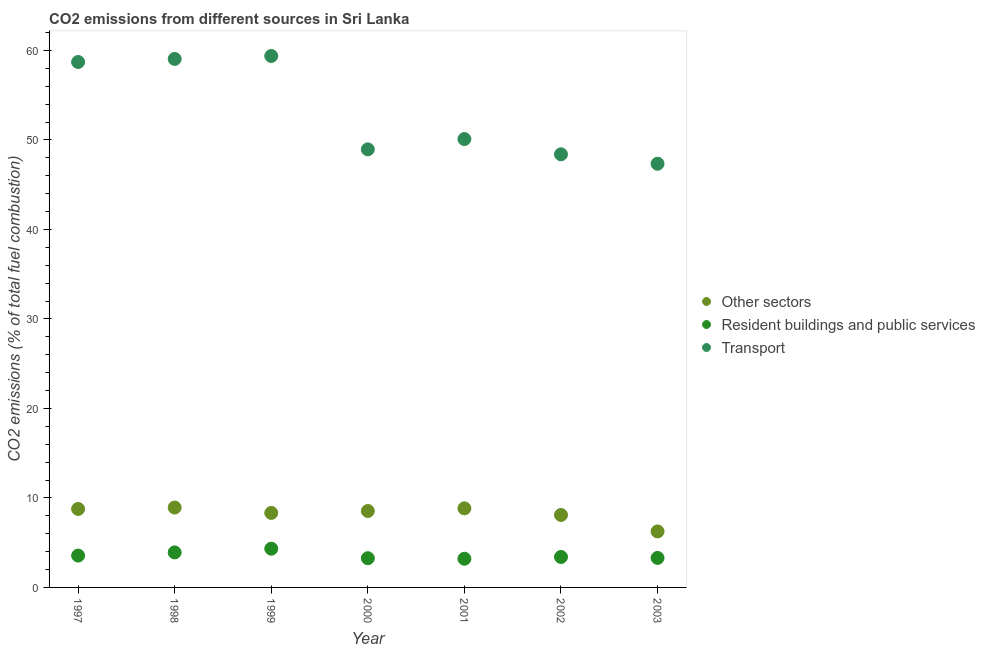How many different coloured dotlines are there?
Your answer should be compact. 3. What is the percentage of co2 emissions from transport in 1997?
Your response must be concise. 58.7. Across all years, what is the maximum percentage of co2 emissions from resident buildings and public services?
Provide a short and direct response. 4.33. Across all years, what is the minimum percentage of co2 emissions from other sectors?
Your response must be concise. 6.26. What is the total percentage of co2 emissions from resident buildings and public services in the graph?
Ensure brevity in your answer.  24.97. What is the difference between the percentage of co2 emissions from other sectors in 1999 and that in 2001?
Your response must be concise. -0.51. What is the difference between the percentage of co2 emissions from other sectors in 2001 and the percentage of co2 emissions from transport in 1998?
Keep it short and to the point. -50.21. What is the average percentage of co2 emissions from transport per year?
Give a very brief answer. 53.13. In the year 1999, what is the difference between the percentage of co2 emissions from resident buildings and public services and percentage of co2 emissions from transport?
Ensure brevity in your answer.  -55.05. What is the ratio of the percentage of co2 emissions from resident buildings and public services in 1998 to that in 2002?
Your answer should be compact. 1.15. Is the percentage of co2 emissions from resident buildings and public services in 1999 less than that in 2002?
Give a very brief answer. No. Is the difference between the percentage of co2 emissions from transport in 1997 and 1999 greater than the difference between the percentage of co2 emissions from resident buildings and public services in 1997 and 1999?
Provide a short and direct response. Yes. What is the difference between the highest and the second highest percentage of co2 emissions from transport?
Your answer should be compact. 0.33. What is the difference between the highest and the lowest percentage of co2 emissions from resident buildings and public services?
Provide a succinct answer. 1.12. Is the sum of the percentage of co2 emissions from other sectors in 1997 and 1999 greater than the maximum percentage of co2 emissions from resident buildings and public services across all years?
Provide a succinct answer. Yes. Is it the case that in every year, the sum of the percentage of co2 emissions from other sectors and percentage of co2 emissions from resident buildings and public services is greater than the percentage of co2 emissions from transport?
Your answer should be very brief. No. Is the percentage of co2 emissions from other sectors strictly greater than the percentage of co2 emissions from resident buildings and public services over the years?
Keep it short and to the point. Yes. What is the difference between two consecutive major ticks on the Y-axis?
Keep it short and to the point. 10. Does the graph contain grids?
Provide a short and direct response. No. Where does the legend appear in the graph?
Keep it short and to the point. Center right. How many legend labels are there?
Your answer should be very brief. 3. How are the legend labels stacked?
Give a very brief answer. Vertical. What is the title of the graph?
Your answer should be compact. CO2 emissions from different sources in Sri Lanka. What is the label or title of the X-axis?
Keep it short and to the point. Year. What is the label or title of the Y-axis?
Make the answer very short. CO2 emissions (% of total fuel combustion). What is the CO2 emissions (% of total fuel combustion) of Other sectors in 1997?
Give a very brief answer. 8.77. What is the CO2 emissions (% of total fuel combustion) in Resident buildings and public services in 1997?
Provide a short and direct response. 3.56. What is the CO2 emissions (% of total fuel combustion) in Transport in 1997?
Ensure brevity in your answer.  58.7. What is the CO2 emissions (% of total fuel combustion) in Other sectors in 1998?
Offer a very short reply. 8.92. What is the CO2 emissions (% of total fuel combustion) of Resident buildings and public services in 1998?
Provide a succinct answer. 3.91. What is the CO2 emissions (% of total fuel combustion) in Transport in 1998?
Offer a terse response. 59.05. What is the CO2 emissions (% of total fuel combustion) of Other sectors in 1999?
Your answer should be compact. 8.32. What is the CO2 emissions (% of total fuel combustion) in Resident buildings and public services in 1999?
Your answer should be compact. 4.33. What is the CO2 emissions (% of total fuel combustion) in Transport in 1999?
Make the answer very short. 59.38. What is the CO2 emissions (% of total fuel combustion) of Other sectors in 2000?
Your answer should be compact. 8.54. What is the CO2 emissions (% of total fuel combustion) in Resident buildings and public services in 2000?
Ensure brevity in your answer.  3.26. What is the CO2 emissions (% of total fuel combustion) in Transport in 2000?
Give a very brief answer. 48.94. What is the CO2 emissions (% of total fuel combustion) in Other sectors in 2001?
Provide a short and direct response. 8.83. What is the CO2 emissions (% of total fuel combustion) of Resident buildings and public services in 2001?
Give a very brief answer. 3.2. What is the CO2 emissions (% of total fuel combustion) in Transport in 2001?
Provide a succinct answer. 50.1. What is the CO2 emissions (% of total fuel combustion) in Other sectors in 2002?
Offer a very short reply. 8.1. What is the CO2 emissions (% of total fuel combustion) in Resident buildings and public services in 2002?
Give a very brief answer. 3.4. What is the CO2 emissions (% of total fuel combustion) in Transport in 2002?
Make the answer very short. 48.39. What is the CO2 emissions (% of total fuel combustion) of Other sectors in 2003?
Make the answer very short. 6.26. What is the CO2 emissions (% of total fuel combustion) of Resident buildings and public services in 2003?
Offer a terse response. 3.3. What is the CO2 emissions (% of total fuel combustion) of Transport in 2003?
Provide a short and direct response. 47.34. Across all years, what is the maximum CO2 emissions (% of total fuel combustion) of Other sectors?
Keep it short and to the point. 8.92. Across all years, what is the maximum CO2 emissions (% of total fuel combustion) of Resident buildings and public services?
Offer a very short reply. 4.33. Across all years, what is the maximum CO2 emissions (% of total fuel combustion) of Transport?
Give a very brief answer. 59.38. Across all years, what is the minimum CO2 emissions (% of total fuel combustion) in Other sectors?
Give a very brief answer. 6.26. Across all years, what is the minimum CO2 emissions (% of total fuel combustion) in Resident buildings and public services?
Provide a succinct answer. 3.2. Across all years, what is the minimum CO2 emissions (% of total fuel combustion) of Transport?
Make the answer very short. 47.34. What is the total CO2 emissions (% of total fuel combustion) of Other sectors in the graph?
Offer a very short reply. 57.74. What is the total CO2 emissions (% of total fuel combustion) in Resident buildings and public services in the graph?
Keep it short and to the point. 24.97. What is the total CO2 emissions (% of total fuel combustion) of Transport in the graph?
Provide a succinct answer. 371.9. What is the difference between the CO2 emissions (% of total fuel combustion) in Other sectors in 1997 and that in 1998?
Ensure brevity in your answer.  -0.16. What is the difference between the CO2 emissions (% of total fuel combustion) in Resident buildings and public services in 1997 and that in 1998?
Your answer should be very brief. -0.35. What is the difference between the CO2 emissions (% of total fuel combustion) of Transport in 1997 and that in 1998?
Make the answer very short. -0.34. What is the difference between the CO2 emissions (% of total fuel combustion) in Other sectors in 1997 and that in 1999?
Your response must be concise. 0.44. What is the difference between the CO2 emissions (% of total fuel combustion) in Resident buildings and public services in 1997 and that in 1999?
Your answer should be compact. -0.77. What is the difference between the CO2 emissions (% of total fuel combustion) in Transport in 1997 and that in 1999?
Provide a short and direct response. -0.67. What is the difference between the CO2 emissions (% of total fuel combustion) in Other sectors in 1997 and that in 2000?
Make the answer very short. 0.23. What is the difference between the CO2 emissions (% of total fuel combustion) of Resident buildings and public services in 1997 and that in 2000?
Your response must be concise. 0.29. What is the difference between the CO2 emissions (% of total fuel combustion) of Transport in 1997 and that in 2000?
Your answer should be very brief. 9.76. What is the difference between the CO2 emissions (% of total fuel combustion) in Other sectors in 1997 and that in 2001?
Your response must be concise. -0.07. What is the difference between the CO2 emissions (% of total fuel combustion) of Resident buildings and public services in 1997 and that in 2001?
Your answer should be compact. 0.35. What is the difference between the CO2 emissions (% of total fuel combustion) of Transport in 1997 and that in 2001?
Your response must be concise. 8.61. What is the difference between the CO2 emissions (% of total fuel combustion) in Other sectors in 1997 and that in 2002?
Your response must be concise. 0.67. What is the difference between the CO2 emissions (% of total fuel combustion) in Resident buildings and public services in 1997 and that in 2002?
Provide a short and direct response. 0.15. What is the difference between the CO2 emissions (% of total fuel combustion) of Transport in 1997 and that in 2002?
Provide a succinct answer. 10.31. What is the difference between the CO2 emissions (% of total fuel combustion) in Other sectors in 1997 and that in 2003?
Ensure brevity in your answer.  2.51. What is the difference between the CO2 emissions (% of total fuel combustion) in Resident buildings and public services in 1997 and that in 2003?
Provide a succinct answer. 0.26. What is the difference between the CO2 emissions (% of total fuel combustion) of Transport in 1997 and that in 2003?
Provide a short and direct response. 11.37. What is the difference between the CO2 emissions (% of total fuel combustion) of Other sectors in 1998 and that in 1999?
Your response must be concise. 0.6. What is the difference between the CO2 emissions (% of total fuel combustion) in Resident buildings and public services in 1998 and that in 1999?
Provide a short and direct response. -0.42. What is the difference between the CO2 emissions (% of total fuel combustion) of Transport in 1998 and that in 1999?
Make the answer very short. -0.33. What is the difference between the CO2 emissions (% of total fuel combustion) in Other sectors in 1998 and that in 2000?
Offer a terse response. 0.38. What is the difference between the CO2 emissions (% of total fuel combustion) in Resident buildings and public services in 1998 and that in 2000?
Your response must be concise. 0.65. What is the difference between the CO2 emissions (% of total fuel combustion) of Transport in 1998 and that in 2000?
Give a very brief answer. 10.1. What is the difference between the CO2 emissions (% of total fuel combustion) of Other sectors in 1998 and that in 2001?
Your answer should be compact. 0.09. What is the difference between the CO2 emissions (% of total fuel combustion) in Resident buildings and public services in 1998 and that in 2001?
Provide a succinct answer. 0.71. What is the difference between the CO2 emissions (% of total fuel combustion) in Transport in 1998 and that in 2001?
Your answer should be compact. 8.95. What is the difference between the CO2 emissions (% of total fuel combustion) of Other sectors in 1998 and that in 2002?
Keep it short and to the point. 0.83. What is the difference between the CO2 emissions (% of total fuel combustion) in Resident buildings and public services in 1998 and that in 2002?
Keep it short and to the point. 0.51. What is the difference between the CO2 emissions (% of total fuel combustion) of Transport in 1998 and that in 2002?
Keep it short and to the point. 10.66. What is the difference between the CO2 emissions (% of total fuel combustion) in Other sectors in 1998 and that in 2003?
Your answer should be compact. 2.67. What is the difference between the CO2 emissions (% of total fuel combustion) in Resident buildings and public services in 1998 and that in 2003?
Keep it short and to the point. 0.62. What is the difference between the CO2 emissions (% of total fuel combustion) in Transport in 1998 and that in 2003?
Make the answer very short. 11.71. What is the difference between the CO2 emissions (% of total fuel combustion) in Other sectors in 1999 and that in 2000?
Provide a succinct answer. -0.22. What is the difference between the CO2 emissions (% of total fuel combustion) of Resident buildings and public services in 1999 and that in 2000?
Your answer should be compact. 1.07. What is the difference between the CO2 emissions (% of total fuel combustion) in Transport in 1999 and that in 2000?
Provide a succinct answer. 10.43. What is the difference between the CO2 emissions (% of total fuel combustion) in Other sectors in 1999 and that in 2001?
Give a very brief answer. -0.51. What is the difference between the CO2 emissions (% of total fuel combustion) of Resident buildings and public services in 1999 and that in 2001?
Provide a short and direct response. 1.12. What is the difference between the CO2 emissions (% of total fuel combustion) of Transport in 1999 and that in 2001?
Your response must be concise. 9.28. What is the difference between the CO2 emissions (% of total fuel combustion) of Other sectors in 1999 and that in 2002?
Make the answer very short. 0.23. What is the difference between the CO2 emissions (% of total fuel combustion) in Resident buildings and public services in 1999 and that in 2002?
Your answer should be very brief. 0.92. What is the difference between the CO2 emissions (% of total fuel combustion) of Transport in 1999 and that in 2002?
Offer a very short reply. 10.99. What is the difference between the CO2 emissions (% of total fuel combustion) of Other sectors in 1999 and that in 2003?
Ensure brevity in your answer.  2.07. What is the difference between the CO2 emissions (% of total fuel combustion) of Resident buildings and public services in 1999 and that in 2003?
Your response must be concise. 1.03. What is the difference between the CO2 emissions (% of total fuel combustion) of Transport in 1999 and that in 2003?
Offer a terse response. 12.04. What is the difference between the CO2 emissions (% of total fuel combustion) of Other sectors in 2000 and that in 2001?
Offer a terse response. -0.29. What is the difference between the CO2 emissions (% of total fuel combustion) in Resident buildings and public services in 2000 and that in 2001?
Provide a short and direct response. 0.06. What is the difference between the CO2 emissions (% of total fuel combustion) in Transport in 2000 and that in 2001?
Ensure brevity in your answer.  -1.15. What is the difference between the CO2 emissions (% of total fuel combustion) of Other sectors in 2000 and that in 2002?
Give a very brief answer. 0.45. What is the difference between the CO2 emissions (% of total fuel combustion) of Resident buildings and public services in 2000 and that in 2002?
Your response must be concise. -0.14. What is the difference between the CO2 emissions (% of total fuel combustion) in Transport in 2000 and that in 2002?
Offer a very short reply. 0.55. What is the difference between the CO2 emissions (% of total fuel combustion) in Other sectors in 2000 and that in 2003?
Ensure brevity in your answer.  2.29. What is the difference between the CO2 emissions (% of total fuel combustion) in Resident buildings and public services in 2000 and that in 2003?
Give a very brief answer. -0.03. What is the difference between the CO2 emissions (% of total fuel combustion) of Transport in 2000 and that in 2003?
Provide a short and direct response. 1.61. What is the difference between the CO2 emissions (% of total fuel combustion) in Other sectors in 2001 and that in 2002?
Ensure brevity in your answer.  0.74. What is the difference between the CO2 emissions (% of total fuel combustion) of Transport in 2001 and that in 2002?
Your response must be concise. 1.71. What is the difference between the CO2 emissions (% of total fuel combustion) in Other sectors in 2001 and that in 2003?
Give a very brief answer. 2.58. What is the difference between the CO2 emissions (% of total fuel combustion) of Resident buildings and public services in 2001 and that in 2003?
Provide a succinct answer. -0.09. What is the difference between the CO2 emissions (% of total fuel combustion) in Transport in 2001 and that in 2003?
Ensure brevity in your answer.  2.76. What is the difference between the CO2 emissions (% of total fuel combustion) of Other sectors in 2002 and that in 2003?
Give a very brief answer. 1.84. What is the difference between the CO2 emissions (% of total fuel combustion) of Resident buildings and public services in 2002 and that in 2003?
Your answer should be very brief. 0.11. What is the difference between the CO2 emissions (% of total fuel combustion) of Transport in 2002 and that in 2003?
Provide a succinct answer. 1.05. What is the difference between the CO2 emissions (% of total fuel combustion) of Other sectors in 1997 and the CO2 emissions (% of total fuel combustion) of Resident buildings and public services in 1998?
Give a very brief answer. 4.86. What is the difference between the CO2 emissions (% of total fuel combustion) of Other sectors in 1997 and the CO2 emissions (% of total fuel combustion) of Transport in 1998?
Give a very brief answer. -50.28. What is the difference between the CO2 emissions (% of total fuel combustion) in Resident buildings and public services in 1997 and the CO2 emissions (% of total fuel combustion) in Transport in 1998?
Your answer should be very brief. -55.49. What is the difference between the CO2 emissions (% of total fuel combustion) of Other sectors in 1997 and the CO2 emissions (% of total fuel combustion) of Resident buildings and public services in 1999?
Provide a succinct answer. 4.44. What is the difference between the CO2 emissions (% of total fuel combustion) in Other sectors in 1997 and the CO2 emissions (% of total fuel combustion) in Transport in 1999?
Your answer should be very brief. -50.61. What is the difference between the CO2 emissions (% of total fuel combustion) in Resident buildings and public services in 1997 and the CO2 emissions (% of total fuel combustion) in Transport in 1999?
Your answer should be very brief. -55.82. What is the difference between the CO2 emissions (% of total fuel combustion) of Other sectors in 1997 and the CO2 emissions (% of total fuel combustion) of Resident buildings and public services in 2000?
Give a very brief answer. 5.5. What is the difference between the CO2 emissions (% of total fuel combustion) of Other sectors in 1997 and the CO2 emissions (% of total fuel combustion) of Transport in 2000?
Ensure brevity in your answer.  -40.18. What is the difference between the CO2 emissions (% of total fuel combustion) of Resident buildings and public services in 1997 and the CO2 emissions (% of total fuel combustion) of Transport in 2000?
Make the answer very short. -45.39. What is the difference between the CO2 emissions (% of total fuel combustion) of Other sectors in 1997 and the CO2 emissions (% of total fuel combustion) of Resident buildings and public services in 2001?
Provide a succinct answer. 5.56. What is the difference between the CO2 emissions (% of total fuel combustion) in Other sectors in 1997 and the CO2 emissions (% of total fuel combustion) in Transport in 2001?
Offer a very short reply. -41.33. What is the difference between the CO2 emissions (% of total fuel combustion) of Resident buildings and public services in 1997 and the CO2 emissions (% of total fuel combustion) of Transport in 2001?
Offer a very short reply. -46.54. What is the difference between the CO2 emissions (% of total fuel combustion) of Other sectors in 1997 and the CO2 emissions (% of total fuel combustion) of Resident buildings and public services in 2002?
Keep it short and to the point. 5.36. What is the difference between the CO2 emissions (% of total fuel combustion) of Other sectors in 1997 and the CO2 emissions (% of total fuel combustion) of Transport in 2002?
Offer a terse response. -39.62. What is the difference between the CO2 emissions (% of total fuel combustion) of Resident buildings and public services in 1997 and the CO2 emissions (% of total fuel combustion) of Transport in 2002?
Offer a very short reply. -44.83. What is the difference between the CO2 emissions (% of total fuel combustion) of Other sectors in 1997 and the CO2 emissions (% of total fuel combustion) of Resident buildings and public services in 2003?
Keep it short and to the point. 5.47. What is the difference between the CO2 emissions (% of total fuel combustion) of Other sectors in 1997 and the CO2 emissions (% of total fuel combustion) of Transport in 2003?
Ensure brevity in your answer.  -38.57. What is the difference between the CO2 emissions (% of total fuel combustion) of Resident buildings and public services in 1997 and the CO2 emissions (% of total fuel combustion) of Transport in 2003?
Keep it short and to the point. -43.78. What is the difference between the CO2 emissions (% of total fuel combustion) of Other sectors in 1998 and the CO2 emissions (% of total fuel combustion) of Resident buildings and public services in 1999?
Provide a succinct answer. 4.6. What is the difference between the CO2 emissions (% of total fuel combustion) of Other sectors in 1998 and the CO2 emissions (% of total fuel combustion) of Transport in 1999?
Your answer should be compact. -50.45. What is the difference between the CO2 emissions (% of total fuel combustion) in Resident buildings and public services in 1998 and the CO2 emissions (% of total fuel combustion) in Transport in 1999?
Your answer should be compact. -55.47. What is the difference between the CO2 emissions (% of total fuel combustion) of Other sectors in 1998 and the CO2 emissions (% of total fuel combustion) of Resident buildings and public services in 2000?
Keep it short and to the point. 5.66. What is the difference between the CO2 emissions (% of total fuel combustion) of Other sectors in 1998 and the CO2 emissions (% of total fuel combustion) of Transport in 2000?
Provide a succinct answer. -40.02. What is the difference between the CO2 emissions (% of total fuel combustion) in Resident buildings and public services in 1998 and the CO2 emissions (% of total fuel combustion) in Transport in 2000?
Offer a terse response. -45.03. What is the difference between the CO2 emissions (% of total fuel combustion) in Other sectors in 1998 and the CO2 emissions (% of total fuel combustion) in Resident buildings and public services in 2001?
Make the answer very short. 5.72. What is the difference between the CO2 emissions (% of total fuel combustion) of Other sectors in 1998 and the CO2 emissions (% of total fuel combustion) of Transport in 2001?
Give a very brief answer. -41.17. What is the difference between the CO2 emissions (% of total fuel combustion) in Resident buildings and public services in 1998 and the CO2 emissions (% of total fuel combustion) in Transport in 2001?
Ensure brevity in your answer.  -46.19. What is the difference between the CO2 emissions (% of total fuel combustion) in Other sectors in 1998 and the CO2 emissions (% of total fuel combustion) in Resident buildings and public services in 2002?
Your answer should be very brief. 5.52. What is the difference between the CO2 emissions (% of total fuel combustion) in Other sectors in 1998 and the CO2 emissions (% of total fuel combustion) in Transport in 2002?
Your response must be concise. -39.47. What is the difference between the CO2 emissions (% of total fuel combustion) in Resident buildings and public services in 1998 and the CO2 emissions (% of total fuel combustion) in Transport in 2002?
Keep it short and to the point. -44.48. What is the difference between the CO2 emissions (% of total fuel combustion) of Other sectors in 1998 and the CO2 emissions (% of total fuel combustion) of Resident buildings and public services in 2003?
Keep it short and to the point. 5.63. What is the difference between the CO2 emissions (% of total fuel combustion) of Other sectors in 1998 and the CO2 emissions (% of total fuel combustion) of Transport in 2003?
Make the answer very short. -38.41. What is the difference between the CO2 emissions (% of total fuel combustion) of Resident buildings and public services in 1998 and the CO2 emissions (% of total fuel combustion) of Transport in 2003?
Offer a terse response. -43.43. What is the difference between the CO2 emissions (% of total fuel combustion) in Other sectors in 1999 and the CO2 emissions (% of total fuel combustion) in Resident buildings and public services in 2000?
Make the answer very short. 5.06. What is the difference between the CO2 emissions (% of total fuel combustion) of Other sectors in 1999 and the CO2 emissions (% of total fuel combustion) of Transport in 2000?
Make the answer very short. -40.62. What is the difference between the CO2 emissions (% of total fuel combustion) in Resident buildings and public services in 1999 and the CO2 emissions (% of total fuel combustion) in Transport in 2000?
Offer a very short reply. -44.62. What is the difference between the CO2 emissions (% of total fuel combustion) of Other sectors in 1999 and the CO2 emissions (% of total fuel combustion) of Resident buildings and public services in 2001?
Your response must be concise. 5.12. What is the difference between the CO2 emissions (% of total fuel combustion) in Other sectors in 1999 and the CO2 emissions (% of total fuel combustion) in Transport in 2001?
Keep it short and to the point. -41.77. What is the difference between the CO2 emissions (% of total fuel combustion) of Resident buildings and public services in 1999 and the CO2 emissions (% of total fuel combustion) of Transport in 2001?
Make the answer very short. -45.77. What is the difference between the CO2 emissions (% of total fuel combustion) in Other sectors in 1999 and the CO2 emissions (% of total fuel combustion) in Resident buildings and public services in 2002?
Provide a succinct answer. 4.92. What is the difference between the CO2 emissions (% of total fuel combustion) in Other sectors in 1999 and the CO2 emissions (% of total fuel combustion) in Transport in 2002?
Provide a succinct answer. -40.07. What is the difference between the CO2 emissions (% of total fuel combustion) in Resident buildings and public services in 1999 and the CO2 emissions (% of total fuel combustion) in Transport in 2002?
Offer a terse response. -44.06. What is the difference between the CO2 emissions (% of total fuel combustion) in Other sectors in 1999 and the CO2 emissions (% of total fuel combustion) in Resident buildings and public services in 2003?
Your answer should be very brief. 5.03. What is the difference between the CO2 emissions (% of total fuel combustion) of Other sectors in 1999 and the CO2 emissions (% of total fuel combustion) of Transport in 2003?
Keep it short and to the point. -39.01. What is the difference between the CO2 emissions (% of total fuel combustion) of Resident buildings and public services in 1999 and the CO2 emissions (% of total fuel combustion) of Transport in 2003?
Make the answer very short. -43.01. What is the difference between the CO2 emissions (% of total fuel combustion) of Other sectors in 2000 and the CO2 emissions (% of total fuel combustion) of Resident buildings and public services in 2001?
Ensure brevity in your answer.  5.34. What is the difference between the CO2 emissions (% of total fuel combustion) of Other sectors in 2000 and the CO2 emissions (% of total fuel combustion) of Transport in 2001?
Your answer should be compact. -41.56. What is the difference between the CO2 emissions (% of total fuel combustion) in Resident buildings and public services in 2000 and the CO2 emissions (% of total fuel combustion) in Transport in 2001?
Make the answer very short. -46.83. What is the difference between the CO2 emissions (% of total fuel combustion) of Other sectors in 2000 and the CO2 emissions (% of total fuel combustion) of Resident buildings and public services in 2002?
Give a very brief answer. 5.14. What is the difference between the CO2 emissions (% of total fuel combustion) of Other sectors in 2000 and the CO2 emissions (% of total fuel combustion) of Transport in 2002?
Provide a short and direct response. -39.85. What is the difference between the CO2 emissions (% of total fuel combustion) of Resident buildings and public services in 2000 and the CO2 emissions (% of total fuel combustion) of Transport in 2002?
Give a very brief answer. -45.13. What is the difference between the CO2 emissions (% of total fuel combustion) in Other sectors in 2000 and the CO2 emissions (% of total fuel combustion) in Resident buildings and public services in 2003?
Make the answer very short. 5.24. What is the difference between the CO2 emissions (% of total fuel combustion) of Other sectors in 2000 and the CO2 emissions (% of total fuel combustion) of Transport in 2003?
Your answer should be very brief. -38.8. What is the difference between the CO2 emissions (% of total fuel combustion) of Resident buildings and public services in 2000 and the CO2 emissions (% of total fuel combustion) of Transport in 2003?
Offer a very short reply. -44.07. What is the difference between the CO2 emissions (% of total fuel combustion) in Other sectors in 2001 and the CO2 emissions (% of total fuel combustion) in Resident buildings and public services in 2002?
Provide a short and direct response. 5.43. What is the difference between the CO2 emissions (% of total fuel combustion) in Other sectors in 2001 and the CO2 emissions (% of total fuel combustion) in Transport in 2002?
Your response must be concise. -39.56. What is the difference between the CO2 emissions (% of total fuel combustion) of Resident buildings and public services in 2001 and the CO2 emissions (% of total fuel combustion) of Transport in 2002?
Provide a succinct answer. -45.19. What is the difference between the CO2 emissions (% of total fuel combustion) in Other sectors in 2001 and the CO2 emissions (% of total fuel combustion) in Resident buildings and public services in 2003?
Make the answer very short. 5.54. What is the difference between the CO2 emissions (% of total fuel combustion) in Other sectors in 2001 and the CO2 emissions (% of total fuel combustion) in Transport in 2003?
Ensure brevity in your answer.  -38.5. What is the difference between the CO2 emissions (% of total fuel combustion) in Resident buildings and public services in 2001 and the CO2 emissions (% of total fuel combustion) in Transport in 2003?
Provide a succinct answer. -44.13. What is the difference between the CO2 emissions (% of total fuel combustion) in Other sectors in 2002 and the CO2 emissions (% of total fuel combustion) in Resident buildings and public services in 2003?
Give a very brief answer. 4.8. What is the difference between the CO2 emissions (% of total fuel combustion) of Other sectors in 2002 and the CO2 emissions (% of total fuel combustion) of Transport in 2003?
Make the answer very short. -39.24. What is the difference between the CO2 emissions (% of total fuel combustion) of Resident buildings and public services in 2002 and the CO2 emissions (% of total fuel combustion) of Transport in 2003?
Your answer should be compact. -43.93. What is the average CO2 emissions (% of total fuel combustion) of Other sectors per year?
Give a very brief answer. 8.25. What is the average CO2 emissions (% of total fuel combustion) in Resident buildings and public services per year?
Offer a very short reply. 3.57. What is the average CO2 emissions (% of total fuel combustion) in Transport per year?
Offer a terse response. 53.13. In the year 1997, what is the difference between the CO2 emissions (% of total fuel combustion) in Other sectors and CO2 emissions (% of total fuel combustion) in Resident buildings and public services?
Provide a short and direct response. 5.21. In the year 1997, what is the difference between the CO2 emissions (% of total fuel combustion) of Other sectors and CO2 emissions (% of total fuel combustion) of Transport?
Make the answer very short. -49.94. In the year 1997, what is the difference between the CO2 emissions (% of total fuel combustion) in Resident buildings and public services and CO2 emissions (% of total fuel combustion) in Transport?
Your answer should be very brief. -55.15. In the year 1998, what is the difference between the CO2 emissions (% of total fuel combustion) in Other sectors and CO2 emissions (% of total fuel combustion) in Resident buildings and public services?
Your answer should be compact. 5.01. In the year 1998, what is the difference between the CO2 emissions (% of total fuel combustion) in Other sectors and CO2 emissions (% of total fuel combustion) in Transport?
Your answer should be compact. -50.12. In the year 1998, what is the difference between the CO2 emissions (% of total fuel combustion) of Resident buildings and public services and CO2 emissions (% of total fuel combustion) of Transport?
Ensure brevity in your answer.  -55.13. In the year 1999, what is the difference between the CO2 emissions (% of total fuel combustion) of Other sectors and CO2 emissions (% of total fuel combustion) of Resident buildings and public services?
Your answer should be compact. 4. In the year 1999, what is the difference between the CO2 emissions (% of total fuel combustion) in Other sectors and CO2 emissions (% of total fuel combustion) in Transport?
Give a very brief answer. -51.05. In the year 1999, what is the difference between the CO2 emissions (% of total fuel combustion) in Resident buildings and public services and CO2 emissions (% of total fuel combustion) in Transport?
Provide a short and direct response. -55.05. In the year 2000, what is the difference between the CO2 emissions (% of total fuel combustion) of Other sectors and CO2 emissions (% of total fuel combustion) of Resident buildings and public services?
Offer a very short reply. 5.28. In the year 2000, what is the difference between the CO2 emissions (% of total fuel combustion) of Other sectors and CO2 emissions (% of total fuel combustion) of Transport?
Your answer should be very brief. -40.4. In the year 2000, what is the difference between the CO2 emissions (% of total fuel combustion) of Resident buildings and public services and CO2 emissions (% of total fuel combustion) of Transport?
Provide a short and direct response. -45.68. In the year 2001, what is the difference between the CO2 emissions (% of total fuel combustion) in Other sectors and CO2 emissions (% of total fuel combustion) in Resident buildings and public services?
Provide a short and direct response. 5.63. In the year 2001, what is the difference between the CO2 emissions (% of total fuel combustion) of Other sectors and CO2 emissions (% of total fuel combustion) of Transport?
Your answer should be compact. -41.26. In the year 2001, what is the difference between the CO2 emissions (% of total fuel combustion) in Resident buildings and public services and CO2 emissions (% of total fuel combustion) in Transport?
Your response must be concise. -46.89. In the year 2002, what is the difference between the CO2 emissions (% of total fuel combustion) in Other sectors and CO2 emissions (% of total fuel combustion) in Resident buildings and public services?
Your answer should be compact. 4.69. In the year 2002, what is the difference between the CO2 emissions (% of total fuel combustion) of Other sectors and CO2 emissions (% of total fuel combustion) of Transport?
Make the answer very short. -40.29. In the year 2002, what is the difference between the CO2 emissions (% of total fuel combustion) of Resident buildings and public services and CO2 emissions (% of total fuel combustion) of Transport?
Provide a succinct answer. -44.99. In the year 2003, what is the difference between the CO2 emissions (% of total fuel combustion) of Other sectors and CO2 emissions (% of total fuel combustion) of Resident buildings and public services?
Provide a succinct answer. 2.96. In the year 2003, what is the difference between the CO2 emissions (% of total fuel combustion) in Other sectors and CO2 emissions (% of total fuel combustion) in Transport?
Your answer should be very brief. -41.08. In the year 2003, what is the difference between the CO2 emissions (% of total fuel combustion) of Resident buildings and public services and CO2 emissions (% of total fuel combustion) of Transport?
Ensure brevity in your answer.  -44.04. What is the ratio of the CO2 emissions (% of total fuel combustion) in Other sectors in 1997 to that in 1998?
Give a very brief answer. 0.98. What is the ratio of the CO2 emissions (% of total fuel combustion) in Resident buildings and public services in 1997 to that in 1998?
Your response must be concise. 0.91. What is the ratio of the CO2 emissions (% of total fuel combustion) of Other sectors in 1997 to that in 1999?
Your answer should be very brief. 1.05. What is the ratio of the CO2 emissions (% of total fuel combustion) in Resident buildings and public services in 1997 to that in 1999?
Give a very brief answer. 0.82. What is the ratio of the CO2 emissions (% of total fuel combustion) in Transport in 1997 to that in 1999?
Offer a terse response. 0.99. What is the ratio of the CO2 emissions (% of total fuel combustion) of Other sectors in 1997 to that in 2000?
Keep it short and to the point. 1.03. What is the ratio of the CO2 emissions (% of total fuel combustion) of Resident buildings and public services in 1997 to that in 2000?
Offer a terse response. 1.09. What is the ratio of the CO2 emissions (% of total fuel combustion) in Transport in 1997 to that in 2000?
Offer a very short reply. 1.2. What is the ratio of the CO2 emissions (% of total fuel combustion) in Resident buildings and public services in 1997 to that in 2001?
Offer a very short reply. 1.11. What is the ratio of the CO2 emissions (% of total fuel combustion) of Transport in 1997 to that in 2001?
Offer a very short reply. 1.17. What is the ratio of the CO2 emissions (% of total fuel combustion) in Other sectors in 1997 to that in 2002?
Make the answer very short. 1.08. What is the ratio of the CO2 emissions (% of total fuel combustion) in Resident buildings and public services in 1997 to that in 2002?
Your response must be concise. 1.05. What is the ratio of the CO2 emissions (% of total fuel combustion) of Transport in 1997 to that in 2002?
Your response must be concise. 1.21. What is the ratio of the CO2 emissions (% of total fuel combustion) of Other sectors in 1997 to that in 2003?
Give a very brief answer. 1.4. What is the ratio of the CO2 emissions (% of total fuel combustion) in Resident buildings and public services in 1997 to that in 2003?
Ensure brevity in your answer.  1.08. What is the ratio of the CO2 emissions (% of total fuel combustion) in Transport in 1997 to that in 2003?
Provide a short and direct response. 1.24. What is the ratio of the CO2 emissions (% of total fuel combustion) in Other sectors in 1998 to that in 1999?
Give a very brief answer. 1.07. What is the ratio of the CO2 emissions (% of total fuel combustion) in Resident buildings and public services in 1998 to that in 1999?
Your response must be concise. 0.9. What is the ratio of the CO2 emissions (% of total fuel combustion) of Transport in 1998 to that in 1999?
Offer a very short reply. 0.99. What is the ratio of the CO2 emissions (% of total fuel combustion) of Other sectors in 1998 to that in 2000?
Provide a short and direct response. 1.04. What is the ratio of the CO2 emissions (% of total fuel combustion) in Resident buildings and public services in 1998 to that in 2000?
Offer a terse response. 1.2. What is the ratio of the CO2 emissions (% of total fuel combustion) of Transport in 1998 to that in 2000?
Offer a terse response. 1.21. What is the ratio of the CO2 emissions (% of total fuel combustion) in Resident buildings and public services in 1998 to that in 2001?
Your response must be concise. 1.22. What is the ratio of the CO2 emissions (% of total fuel combustion) in Transport in 1998 to that in 2001?
Keep it short and to the point. 1.18. What is the ratio of the CO2 emissions (% of total fuel combustion) of Other sectors in 1998 to that in 2002?
Offer a very short reply. 1.1. What is the ratio of the CO2 emissions (% of total fuel combustion) of Resident buildings and public services in 1998 to that in 2002?
Provide a short and direct response. 1.15. What is the ratio of the CO2 emissions (% of total fuel combustion) in Transport in 1998 to that in 2002?
Provide a short and direct response. 1.22. What is the ratio of the CO2 emissions (% of total fuel combustion) in Other sectors in 1998 to that in 2003?
Keep it short and to the point. 1.43. What is the ratio of the CO2 emissions (% of total fuel combustion) in Resident buildings and public services in 1998 to that in 2003?
Keep it short and to the point. 1.19. What is the ratio of the CO2 emissions (% of total fuel combustion) of Transport in 1998 to that in 2003?
Your response must be concise. 1.25. What is the ratio of the CO2 emissions (% of total fuel combustion) in Other sectors in 1999 to that in 2000?
Provide a short and direct response. 0.97. What is the ratio of the CO2 emissions (% of total fuel combustion) in Resident buildings and public services in 1999 to that in 2000?
Give a very brief answer. 1.33. What is the ratio of the CO2 emissions (% of total fuel combustion) in Transport in 1999 to that in 2000?
Offer a very short reply. 1.21. What is the ratio of the CO2 emissions (% of total fuel combustion) in Other sectors in 1999 to that in 2001?
Offer a terse response. 0.94. What is the ratio of the CO2 emissions (% of total fuel combustion) of Resident buildings and public services in 1999 to that in 2001?
Your response must be concise. 1.35. What is the ratio of the CO2 emissions (% of total fuel combustion) of Transport in 1999 to that in 2001?
Your answer should be compact. 1.19. What is the ratio of the CO2 emissions (% of total fuel combustion) of Other sectors in 1999 to that in 2002?
Offer a very short reply. 1.03. What is the ratio of the CO2 emissions (% of total fuel combustion) of Resident buildings and public services in 1999 to that in 2002?
Your answer should be compact. 1.27. What is the ratio of the CO2 emissions (% of total fuel combustion) in Transport in 1999 to that in 2002?
Provide a short and direct response. 1.23. What is the ratio of the CO2 emissions (% of total fuel combustion) of Other sectors in 1999 to that in 2003?
Make the answer very short. 1.33. What is the ratio of the CO2 emissions (% of total fuel combustion) in Resident buildings and public services in 1999 to that in 2003?
Offer a terse response. 1.31. What is the ratio of the CO2 emissions (% of total fuel combustion) of Transport in 1999 to that in 2003?
Provide a succinct answer. 1.25. What is the ratio of the CO2 emissions (% of total fuel combustion) of Other sectors in 2000 to that in 2001?
Your answer should be very brief. 0.97. What is the ratio of the CO2 emissions (% of total fuel combustion) in Resident buildings and public services in 2000 to that in 2001?
Make the answer very short. 1.02. What is the ratio of the CO2 emissions (% of total fuel combustion) in Other sectors in 2000 to that in 2002?
Keep it short and to the point. 1.05. What is the ratio of the CO2 emissions (% of total fuel combustion) of Resident buildings and public services in 2000 to that in 2002?
Give a very brief answer. 0.96. What is the ratio of the CO2 emissions (% of total fuel combustion) in Transport in 2000 to that in 2002?
Provide a short and direct response. 1.01. What is the ratio of the CO2 emissions (% of total fuel combustion) in Other sectors in 2000 to that in 2003?
Your answer should be compact. 1.37. What is the ratio of the CO2 emissions (% of total fuel combustion) in Transport in 2000 to that in 2003?
Offer a very short reply. 1.03. What is the ratio of the CO2 emissions (% of total fuel combustion) in Other sectors in 2001 to that in 2002?
Your answer should be compact. 1.09. What is the ratio of the CO2 emissions (% of total fuel combustion) of Resident buildings and public services in 2001 to that in 2002?
Keep it short and to the point. 0.94. What is the ratio of the CO2 emissions (% of total fuel combustion) in Transport in 2001 to that in 2002?
Provide a succinct answer. 1.04. What is the ratio of the CO2 emissions (% of total fuel combustion) in Other sectors in 2001 to that in 2003?
Offer a very short reply. 1.41. What is the ratio of the CO2 emissions (% of total fuel combustion) of Resident buildings and public services in 2001 to that in 2003?
Keep it short and to the point. 0.97. What is the ratio of the CO2 emissions (% of total fuel combustion) of Transport in 2001 to that in 2003?
Offer a very short reply. 1.06. What is the ratio of the CO2 emissions (% of total fuel combustion) of Other sectors in 2002 to that in 2003?
Offer a very short reply. 1.29. What is the ratio of the CO2 emissions (% of total fuel combustion) in Resident buildings and public services in 2002 to that in 2003?
Your answer should be very brief. 1.03. What is the ratio of the CO2 emissions (% of total fuel combustion) in Transport in 2002 to that in 2003?
Offer a very short reply. 1.02. What is the difference between the highest and the second highest CO2 emissions (% of total fuel combustion) in Other sectors?
Keep it short and to the point. 0.09. What is the difference between the highest and the second highest CO2 emissions (% of total fuel combustion) of Resident buildings and public services?
Your answer should be very brief. 0.42. What is the difference between the highest and the second highest CO2 emissions (% of total fuel combustion) in Transport?
Make the answer very short. 0.33. What is the difference between the highest and the lowest CO2 emissions (% of total fuel combustion) of Other sectors?
Give a very brief answer. 2.67. What is the difference between the highest and the lowest CO2 emissions (% of total fuel combustion) of Resident buildings and public services?
Ensure brevity in your answer.  1.12. What is the difference between the highest and the lowest CO2 emissions (% of total fuel combustion) in Transport?
Provide a succinct answer. 12.04. 